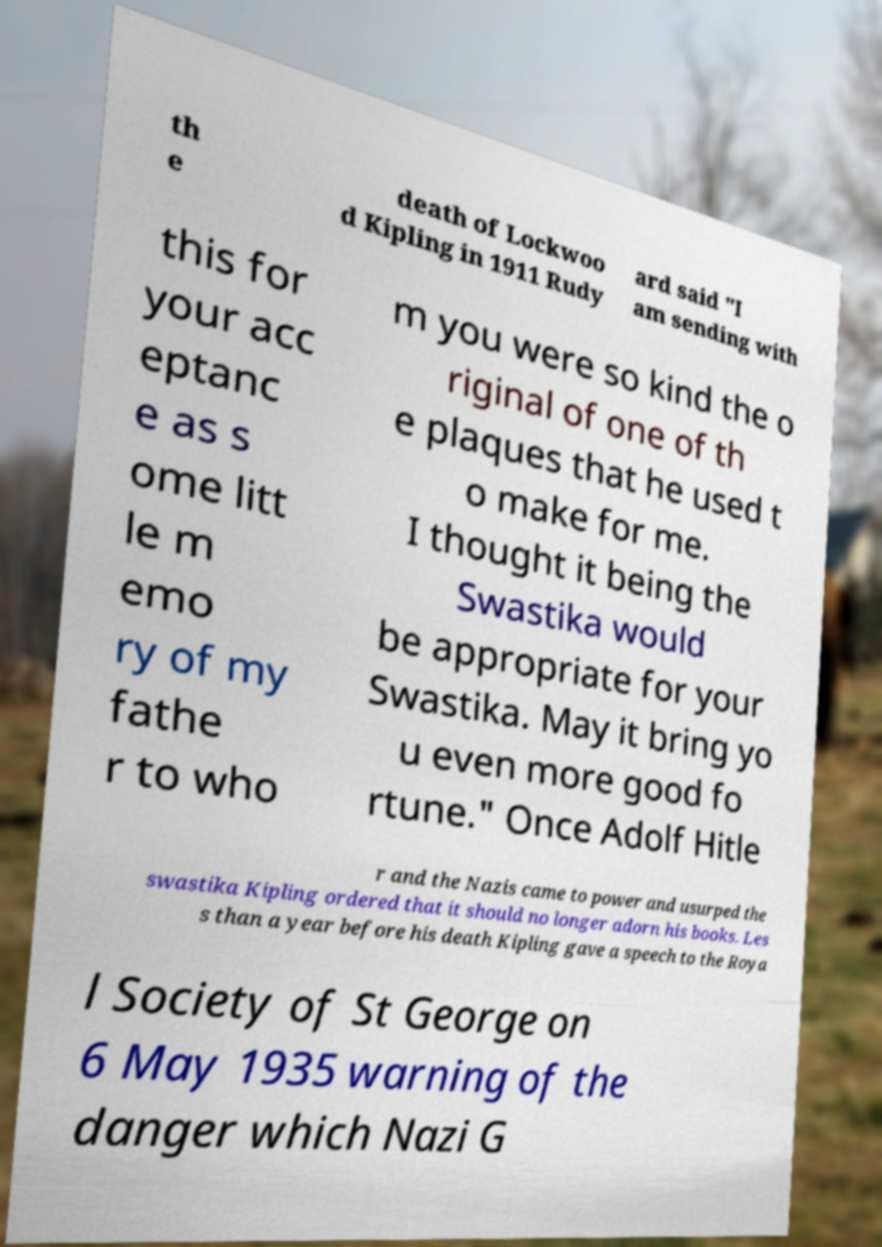What messages or text are displayed in this image? I need them in a readable, typed format. th e death of Lockwoo d Kipling in 1911 Rudy ard said "I am sending with this for your acc eptanc e as s ome litt le m emo ry of my fathe r to who m you were so kind the o riginal of one of th e plaques that he used t o make for me. I thought it being the Swastika would be appropriate for your Swastika. May it bring yo u even more good fo rtune." Once Adolf Hitle r and the Nazis came to power and usurped the swastika Kipling ordered that it should no longer adorn his books. Les s than a year before his death Kipling gave a speech to the Roya l Society of St George on 6 May 1935 warning of the danger which Nazi G 